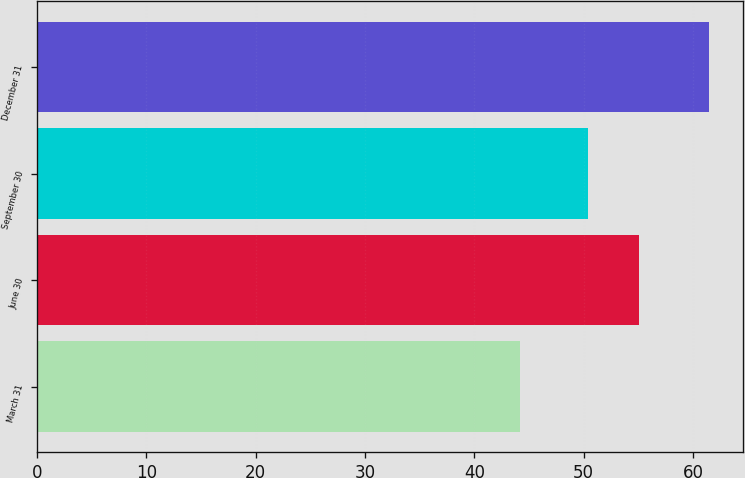Convert chart. <chart><loc_0><loc_0><loc_500><loc_500><bar_chart><fcel>March 31<fcel>June 30<fcel>September 30<fcel>December 31<nl><fcel>44.18<fcel>55.04<fcel>50.41<fcel>61.5<nl></chart> 